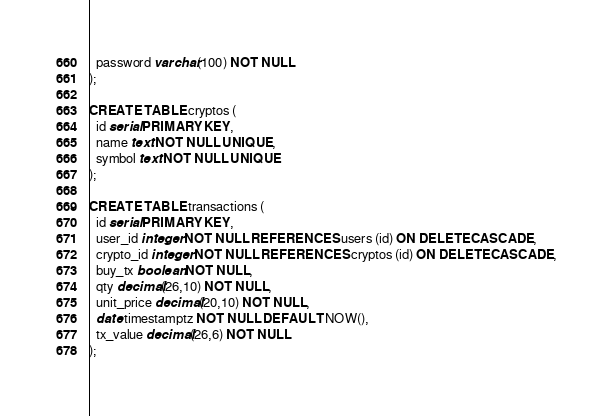<code> <loc_0><loc_0><loc_500><loc_500><_SQL_>  password varchar(100) NOT NULL
);

CREATE TABLE cryptos (
  id serial PRIMARY KEY,
  name text NOT NULL UNIQUE,
  symbol text NOT NULL UNIQUE
);

CREATE TABLE transactions (
  id serial PRIMARY KEY,
  user_id integer NOT NULL REFERENCES users (id) ON DELETE CASCADE,
  crypto_id integer NOT NULL REFERENCES cryptos (id) ON DELETE CASCADE,
  buy_tx boolean NOT NULL,
  qty decimal(26,10) NOT NULL,
  unit_price decimal(20,10) NOT NULL,
  date timestamptz NOT NULL DEFAULT NOW(),
  tx_value decimal(26,6) NOT NULL
);</code> 